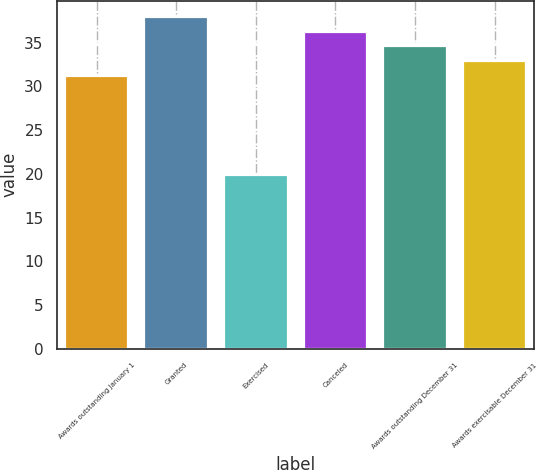<chart> <loc_0><loc_0><loc_500><loc_500><bar_chart><fcel>Awards outstanding January 1<fcel>Granted<fcel>Exercised<fcel>Canceled<fcel>Awards outstanding December 31<fcel>Awards exercisable December 31<nl><fcel>31.24<fcel>37.92<fcel>19.86<fcel>36.25<fcel>34.58<fcel>32.91<nl></chart> 